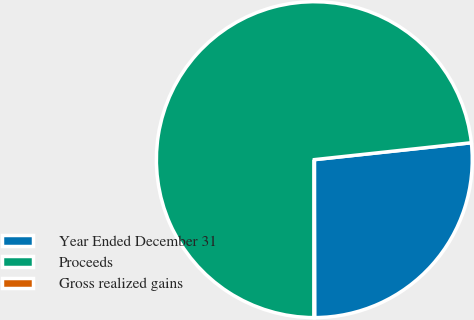Convert chart. <chart><loc_0><loc_0><loc_500><loc_500><pie_chart><fcel>Year Ended December 31<fcel>Proceeds<fcel>Gross realized gains<nl><fcel>26.68%<fcel>73.27%<fcel>0.05%<nl></chart> 